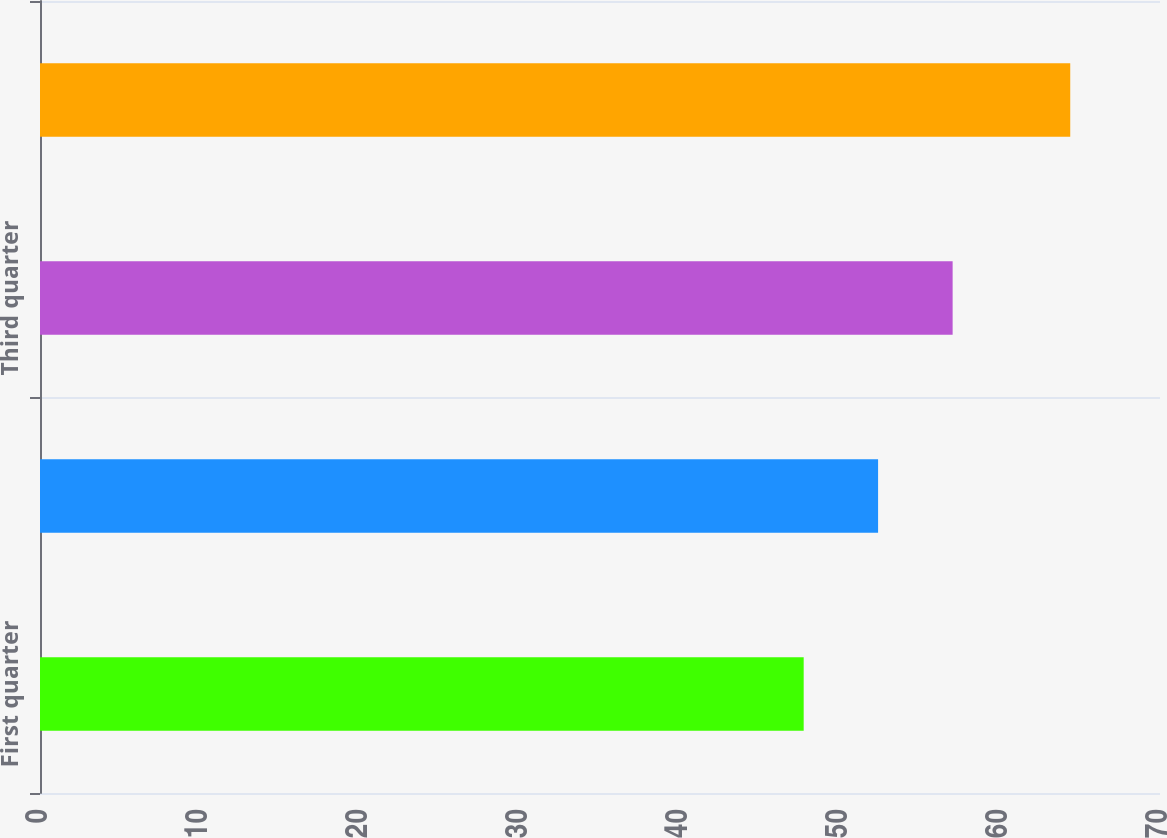Convert chart to OTSL. <chart><loc_0><loc_0><loc_500><loc_500><bar_chart><fcel>First quarter<fcel>Second quarter<fcel>Third quarter<fcel>Fourth quarter<nl><fcel>47.73<fcel>52.38<fcel>57.04<fcel>64.39<nl></chart> 